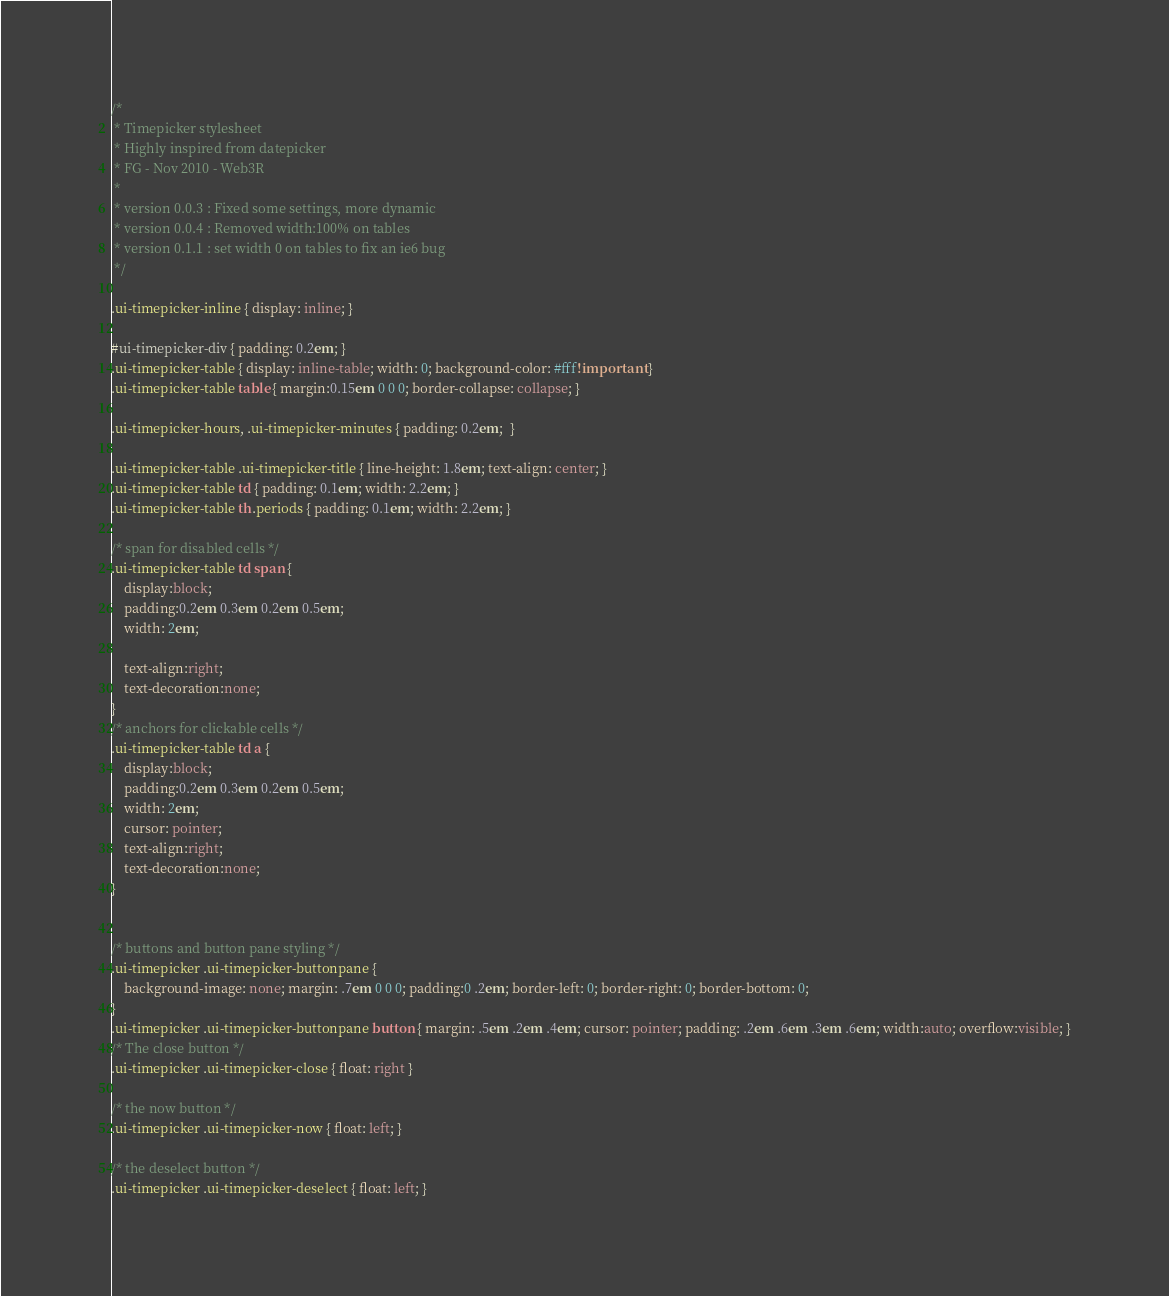<code> <loc_0><loc_0><loc_500><loc_500><_CSS_>/*
 * Timepicker stylesheet
 * Highly inspired from datepicker
 * FG - Nov 2010 - Web3R
 *
 * version 0.0.3 : Fixed some settings, more dynamic
 * version 0.0.4 : Removed width:100% on tables
 * version 0.1.1 : set width 0 on tables to fix an ie6 bug
 */

.ui-timepicker-inline { display: inline; }

#ui-timepicker-div { padding: 0.2em; }
.ui-timepicker-table { display: inline-table; width: 0; background-color: #fff!important }
.ui-timepicker-table table { margin:0.15em 0 0 0; border-collapse: collapse; }

.ui-timepicker-hours, .ui-timepicker-minutes { padding: 0.2em;  }

.ui-timepicker-table .ui-timepicker-title { line-height: 1.8em; text-align: center; }
.ui-timepicker-table td { padding: 0.1em; width: 2.2em; }
.ui-timepicker-table th.periods { padding: 0.1em; width: 2.2em; }

/* span for disabled cells */
.ui-timepicker-table td span {
    display:block;
    padding:0.2em 0.3em 0.2em 0.5em;
    width: 2em;

    text-align:right;
    text-decoration:none;
}
/* anchors for clickable cells */
.ui-timepicker-table td a {
    display:block;
    padding:0.2em 0.3em 0.2em 0.5em;
    width: 2em;
    cursor: pointer;
    text-align:right;
    text-decoration:none;
}


/* buttons and button pane styling */
.ui-timepicker .ui-timepicker-buttonpane {
    background-image: none; margin: .7em 0 0 0; padding:0 .2em; border-left: 0; border-right: 0; border-bottom: 0;
}
.ui-timepicker .ui-timepicker-buttonpane button { margin: .5em .2em .4em; cursor: pointer; padding: .2em .6em .3em .6em; width:auto; overflow:visible; }
/* The close button */
.ui-timepicker .ui-timepicker-close { float: right }

/* the now button */
.ui-timepicker .ui-timepicker-now { float: left; }

/* the deselect button */
.ui-timepicker .ui-timepicker-deselect { float: left; }
</code> 